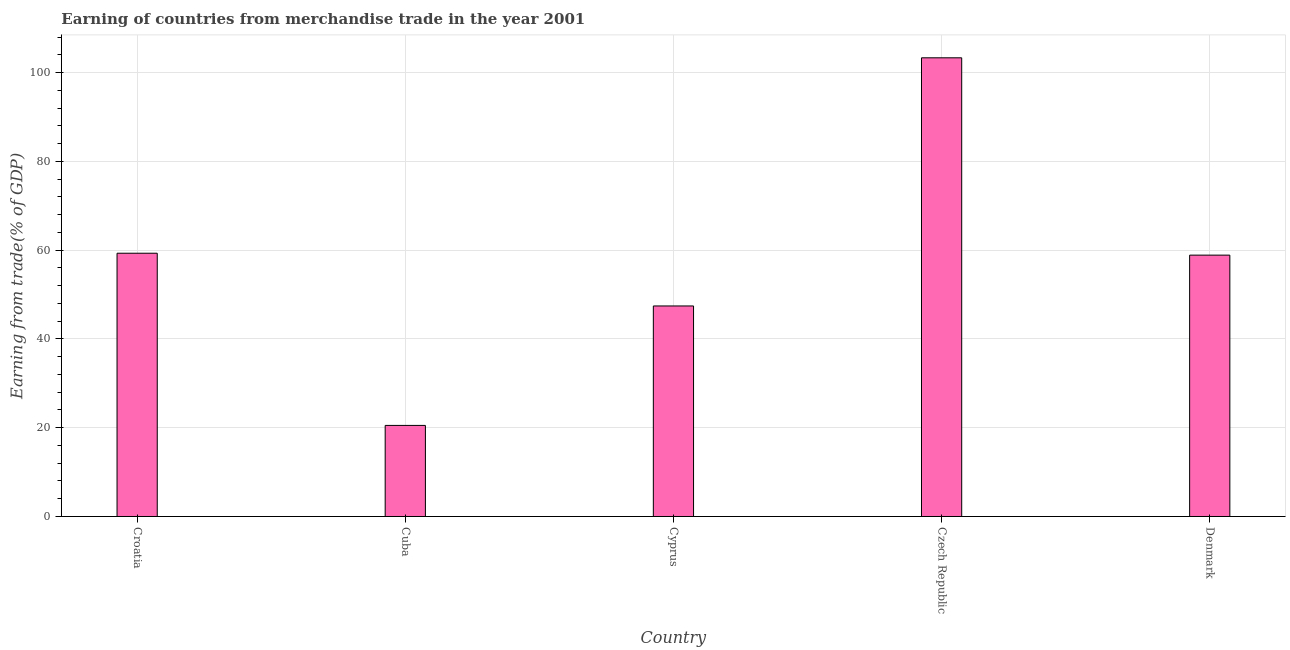Does the graph contain any zero values?
Your answer should be very brief. No. Does the graph contain grids?
Your answer should be compact. Yes. What is the title of the graph?
Offer a very short reply. Earning of countries from merchandise trade in the year 2001. What is the label or title of the Y-axis?
Make the answer very short. Earning from trade(% of GDP). What is the earning from merchandise trade in Croatia?
Your response must be concise. 59.31. Across all countries, what is the maximum earning from merchandise trade?
Your response must be concise. 103.33. Across all countries, what is the minimum earning from merchandise trade?
Your answer should be compact. 20.52. In which country was the earning from merchandise trade maximum?
Your response must be concise. Czech Republic. In which country was the earning from merchandise trade minimum?
Your response must be concise. Cuba. What is the sum of the earning from merchandise trade?
Give a very brief answer. 289.47. What is the difference between the earning from merchandise trade in Cuba and Denmark?
Ensure brevity in your answer.  -38.36. What is the average earning from merchandise trade per country?
Give a very brief answer. 57.89. What is the median earning from merchandise trade?
Keep it short and to the point. 58.88. Is the earning from merchandise trade in Croatia less than that in Cyprus?
Keep it short and to the point. No. Is the difference between the earning from merchandise trade in Cyprus and Czech Republic greater than the difference between any two countries?
Give a very brief answer. No. What is the difference between the highest and the second highest earning from merchandise trade?
Give a very brief answer. 44.02. What is the difference between the highest and the lowest earning from merchandise trade?
Your answer should be compact. 82.82. How many bars are there?
Keep it short and to the point. 5. How many countries are there in the graph?
Give a very brief answer. 5. What is the Earning from trade(% of GDP) of Croatia?
Make the answer very short. 59.31. What is the Earning from trade(% of GDP) in Cuba?
Your response must be concise. 20.52. What is the Earning from trade(% of GDP) in Cyprus?
Offer a terse response. 47.43. What is the Earning from trade(% of GDP) in Czech Republic?
Offer a terse response. 103.33. What is the Earning from trade(% of GDP) in Denmark?
Your answer should be very brief. 58.88. What is the difference between the Earning from trade(% of GDP) in Croatia and Cuba?
Provide a succinct answer. 38.79. What is the difference between the Earning from trade(% of GDP) in Croatia and Cyprus?
Your response must be concise. 11.88. What is the difference between the Earning from trade(% of GDP) in Croatia and Czech Republic?
Provide a short and direct response. -44.02. What is the difference between the Earning from trade(% of GDP) in Croatia and Denmark?
Keep it short and to the point. 0.43. What is the difference between the Earning from trade(% of GDP) in Cuba and Cyprus?
Provide a succinct answer. -26.91. What is the difference between the Earning from trade(% of GDP) in Cuba and Czech Republic?
Your answer should be compact. -82.82. What is the difference between the Earning from trade(% of GDP) in Cuba and Denmark?
Your answer should be compact. -38.36. What is the difference between the Earning from trade(% of GDP) in Cyprus and Czech Republic?
Your answer should be very brief. -55.9. What is the difference between the Earning from trade(% of GDP) in Cyprus and Denmark?
Give a very brief answer. -11.45. What is the difference between the Earning from trade(% of GDP) in Czech Republic and Denmark?
Your response must be concise. 44.45. What is the ratio of the Earning from trade(% of GDP) in Croatia to that in Cuba?
Keep it short and to the point. 2.89. What is the ratio of the Earning from trade(% of GDP) in Croatia to that in Czech Republic?
Your answer should be very brief. 0.57. What is the ratio of the Earning from trade(% of GDP) in Cuba to that in Cyprus?
Make the answer very short. 0.43. What is the ratio of the Earning from trade(% of GDP) in Cuba to that in Czech Republic?
Provide a short and direct response. 0.2. What is the ratio of the Earning from trade(% of GDP) in Cuba to that in Denmark?
Provide a succinct answer. 0.35. What is the ratio of the Earning from trade(% of GDP) in Cyprus to that in Czech Republic?
Offer a terse response. 0.46. What is the ratio of the Earning from trade(% of GDP) in Cyprus to that in Denmark?
Provide a succinct answer. 0.81. What is the ratio of the Earning from trade(% of GDP) in Czech Republic to that in Denmark?
Make the answer very short. 1.75. 